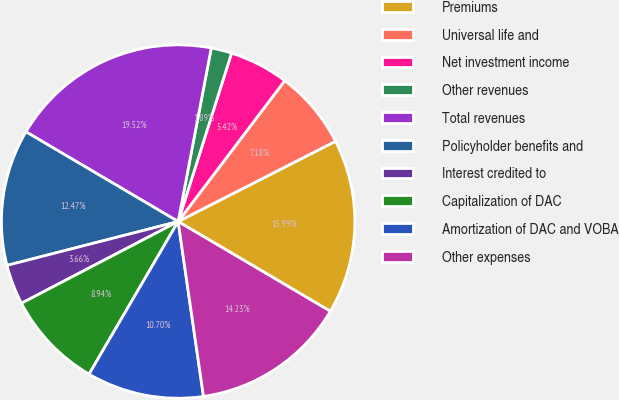Convert chart. <chart><loc_0><loc_0><loc_500><loc_500><pie_chart><fcel>Premiums<fcel>Universal life and<fcel>Net investment income<fcel>Other revenues<fcel>Total revenues<fcel>Policyholder benefits and<fcel>Interest credited to<fcel>Capitalization of DAC<fcel>Amortization of DAC and VOBA<fcel>Other expenses<nl><fcel>15.99%<fcel>7.18%<fcel>5.42%<fcel>1.89%<fcel>19.52%<fcel>12.47%<fcel>3.66%<fcel>8.94%<fcel>10.7%<fcel>14.23%<nl></chart> 